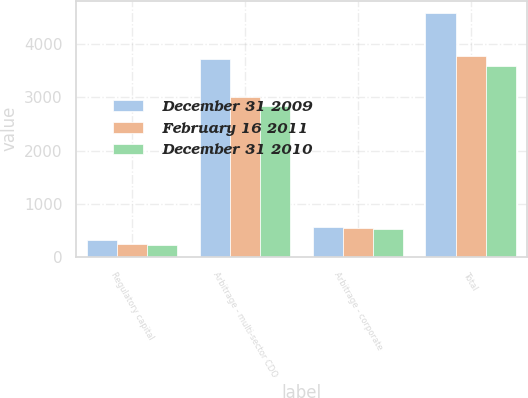Convert chart. <chart><loc_0><loc_0><loc_500><loc_500><stacked_bar_chart><ecel><fcel>Regulatory capital<fcel>Arbitrage - multi-sector CDO<fcel>Arbitrage - corporate<fcel>Total<nl><fcel>December 31 2009<fcel>310<fcel>3715<fcel>565<fcel>4590<nl><fcel>February 16 2011<fcel>236<fcel>3013<fcel>537<fcel>3786<nl><fcel>December 31 2010<fcel>226<fcel>2843<fcel>527<fcel>3596<nl></chart> 